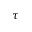<formula> <loc_0><loc_0><loc_500><loc_500>\tau</formula> 